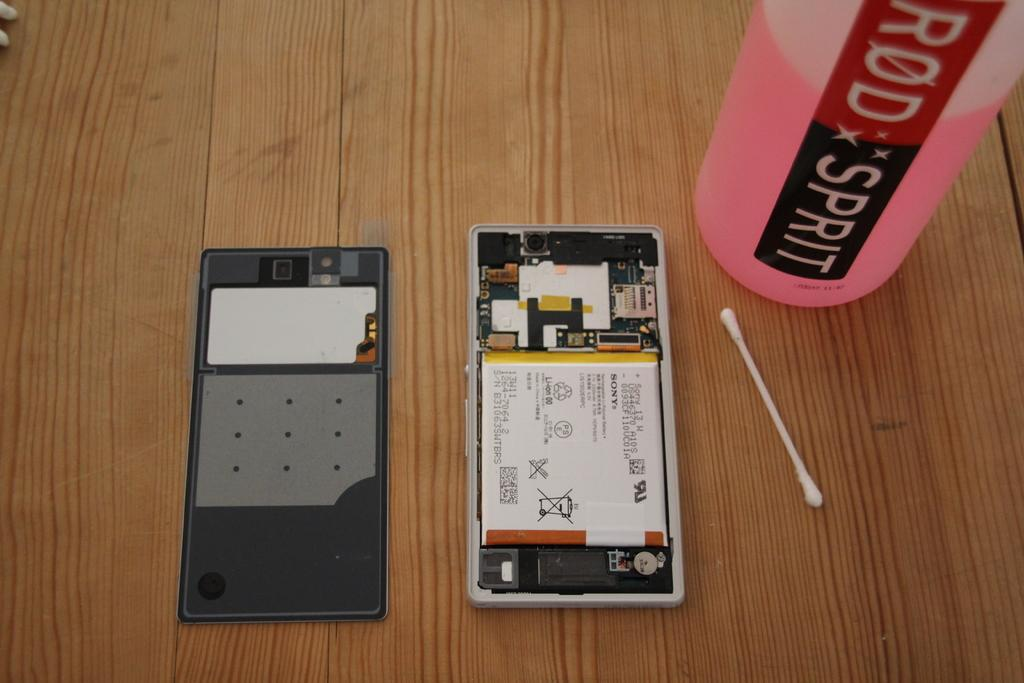<image>
Write a terse but informative summary of the picture. A disassembled cell phone next to a bottle that says ROD SPRIT 